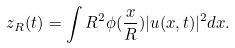Convert formula to latex. <formula><loc_0><loc_0><loc_500><loc_500>z _ { R } ( t ) = \int R ^ { 2 } \phi ( \frac { x } { R } ) | u ( x , t ) | ^ { 2 } d x .</formula> 